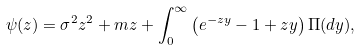<formula> <loc_0><loc_0><loc_500><loc_500>\psi ( z ) = \sigma ^ { 2 } z ^ { 2 } + m z + \int ^ { \infty } _ { 0 } \left ( e ^ { - z y } - 1 + z y \right ) \Pi ( d y ) ,</formula> 